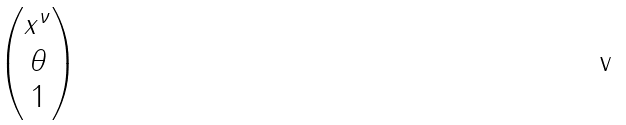<formula> <loc_0><loc_0><loc_500><loc_500>\begin{pmatrix} x ^ { \nu } \\ \theta \\ 1 \end{pmatrix}</formula> 